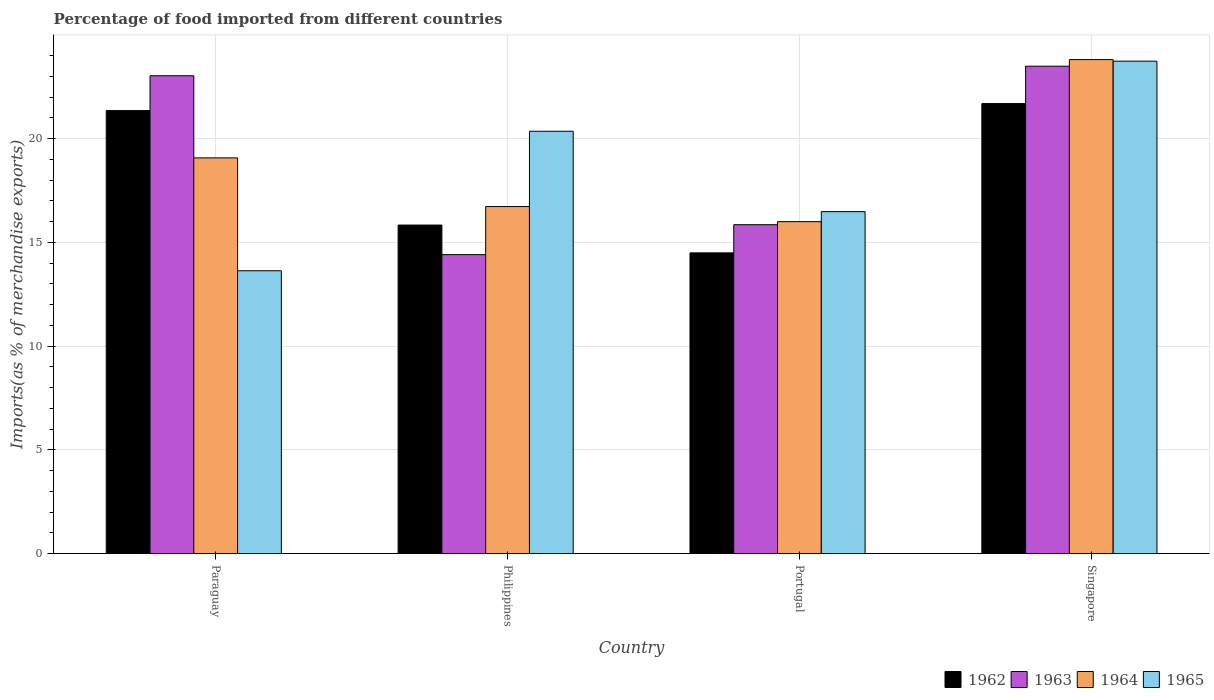How many different coloured bars are there?
Ensure brevity in your answer.  4. Are the number of bars on each tick of the X-axis equal?
Your answer should be very brief. Yes. How many bars are there on the 2nd tick from the left?
Keep it short and to the point. 4. How many bars are there on the 4th tick from the right?
Offer a very short reply. 4. What is the label of the 1st group of bars from the left?
Ensure brevity in your answer.  Paraguay. What is the percentage of imports to different countries in 1963 in Paraguay?
Your answer should be very brief. 23.03. Across all countries, what is the maximum percentage of imports to different countries in 1964?
Ensure brevity in your answer.  23.81. Across all countries, what is the minimum percentage of imports to different countries in 1963?
Keep it short and to the point. 14.41. In which country was the percentage of imports to different countries in 1965 maximum?
Provide a short and direct response. Singapore. What is the total percentage of imports to different countries in 1963 in the graph?
Ensure brevity in your answer.  76.78. What is the difference between the percentage of imports to different countries in 1962 in Portugal and that in Singapore?
Keep it short and to the point. -7.19. What is the difference between the percentage of imports to different countries in 1962 in Singapore and the percentage of imports to different countries in 1964 in Portugal?
Provide a short and direct response. 5.69. What is the average percentage of imports to different countries in 1964 per country?
Make the answer very short. 18.9. What is the difference between the percentage of imports to different countries of/in 1962 and percentage of imports to different countries of/in 1965 in Singapore?
Your answer should be compact. -2.04. In how many countries, is the percentage of imports to different countries in 1965 greater than 6 %?
Provide a succinct answer. 4. What is the ratio of the percentage of imports to different countries in 1963 in Paraguay to that in Philippines?
Your answer should be compact. 1.6. Is the percentage of imports to different countries in 1963 in Philippines less than that in Portugal?
Provide a succinct answer. Yes. Is the difference between the percentage of imports to different countries in 1962 in Paraguay and Singapore greater than the difference between the percentage of imports to different countries in 1965 in Paraguay and Singapore?
Ensure brevity in your answer.  Yes. What is the difference between the highest and the second highest percentage of imports to different countries in 1964?
Your answer should be compact. -2.35. What is the difference between the highest and the lowest percentage of imports to different countries in 1965?
Your answer should be compact. 10.1. Is the sum of the percentage of imports to different countries in 1964 in Paraguay and Portugal greater than the maximum percentage of imports to different countries in 1965 across all countries?
Your answer should be very brief. Yes. What does the 1st bar from the left in Paraguay represents?
Keep it short and to the point. 1962. How many bars are there?
Make the answer very short. 16. What is the difference between two consecutive major ticks on the Y-axis?
Offer a terse response. 5. Are the values on the major ticks of Y-axis written in scientific E-notation?
Provide a short and direct response. No. Where does the legend appear in the graph?
Offer a terse response. Bottom right. How many legend labels are there?
Offer a very short reply. 4. How are the legend labels stacked?
Your response must be concise. Horizontal. What is the title of the graph?
Offer a terse response. Percentage of food imported from different countries. Does "2010" appear as one of the legend labels in the graph?
Offer a terse response. No. What is the label or title of the Y-axis?
Provide a short and direct response. Imports(as % of merchandise exports). What is the Imports(as % of merchandise exports) of 1962 in Paraguay?
Ensure brevity in your answer.  21.35. What is the Imports(as % of merchandise exports) in 1963 in Paraguay?
Your answer should be compact. 23.03. What is the Imports(as % of merchandise exports) in 1964 in Paraguay?
Your answer should be compact. 19.07. What is the Imports(as % of merchandise exports) of 1965 in Paraguay?
Your answer should be very brief. 13.63. What is the Imports(as % of merchandise exports) in 1962 in Philippines?
Ensure brevity in your answer.  15.83. What is the Imports(as % of merchandise exports) of 1963 in Philippines?
Your response must be concise. 14.41. What is the Imports(as % of merchandise exports) in 1964 in Philippines?
Ensure brevity in your answer.  16.73. What is the Imports(as % of merchandise exports) of 1965 in Philippines?
Provide a short and direct response. 20.35. What is the Imports(as % of merchandise exports) in 1962 in Portugal?
Your response must be concise. 14.49. What is the Imports(as % of merchandise exports) in 1963 in Portugal?
Offer a terse response. 15.85. What is the Imports(as % of merchandise exports) of 1964 in Portugal?
Give a very brief answer. 16. What is the Imports(as % of merchandise exports) in 1965 in Portugal?
Offer a terse response. 16.48. What is the Imports(as % of merchandise exports) of 1962 in Singapore?
Provide a short and direct response. 21.69. What is the Imports(as % of merchandise exports) in 1963 in Singapore?
Provide a succinct answer. 23.49. What is the Imports(as % of merchandise exports) of 1964 in Singapore?
Make the answer very short. 23.81. What is the Imports(as % of merchandise exports) in 1965 in Singapore?
Give a very brief answer. 23.73. Across all countries, what is the maximum Imports(as % of merchandise exports) in 1962?
Give a very brief answer. 21.69. Across all countries, what is the maximum Imports(as % of merchandise exports) in 1963?
Your response must be concise. 23.49. Across all countries, what is the maximum Imports(as % of merchandise exports) of 1964?
Offer a very short reply. 23.81. Across all countries, what is the maximum Imports(as % of merchandise exports) in 1965?
Provide a short and direct response. 23.73. Across all countries, what is the minimum Imports(as % of merchandise exports) of 1962?
Offer a terse response. 14.49. Across all countries, what is the minimum Imports(as % of merchandise exports) in 1963?
Your answer should be compact. 14.41. Across all countries, what is the minimum Imports(as % of merchandise exports) in 1964?
Provide a short and direct response. 16. Across all countries, what is the minimum Imports(as % of merchandise exports) in 1965?
Make the answer very short. 13.63. What is the total Imports(as % of merchandise exports) in 1962 in the graph?
Offer a terse response. 73.37. What is the total Imports(as % of merchandise exports) of 1963 in the graph?
Ensure brevity in your answer.  76.78. What is the total Imports(as % of merchandise exports) in 1964 in the graph?
Ensure brevity in your answer.  75.61. What is the total Imports(as % of merchandise exports) in 1965 in the graph?
Provide a succinct answer. 74.2. What is the difference between the Imports(as % of merchandise exports) of 1962 in Paraguay and that in Philippines?
Provide a succinct answer. 5.52. What is the difference between the Imports(as % of merchandise exports) of 1963 in Paraguay and that in Philippines?
Your answer should be very brief. 8.62. What is the difference between the Imports(as % of merchandise exports) in 1964 in Paraguay and that in Philippines?
Your answer should be very brief. 2.35. What is the difference between the Imports(as % of merchandise exports) of 1965 in Paraguay and that in Philippines?
Provide a succinct answer. -6.72. What is the difference between the Imports(as % of merchandise exports) of 1962 in Paraguay and that in Portugal?
Make the answer very short. 6.86. What is the difference between the Imports(as % of merchandise exports) in 1963 in Paraguay and that in Portugal?
Your answer should be compact. 7.18. What is the difference between the Imports(as % of merchandise exports) in 1964 in Paraguay and that in Portugal?
Your answer should be very brief. 3.07. What is the difference between the Imports(as % of merchandise exports) in 1965 in Paraguay and that in Portugal?
Your answer should be compact. -2.85. What is the difference between the Imports(as % of merchandise exports) in 1962 in Paraguay and that in Singapore?
Provide a succinct answer. -0.34. What is the difference between the Imports(as % of merchandise exports) in 1963 in Paraguay and that in Singapore?
Your response must be concise. -0.46. What is the difference between the Imports(as % of merchandise exports) in 1964 in Paraguay and that in Singapore?
Keep it short and to the point. -4.74. What is the difference between the Imports(as % of merchandise exports) in 1965 in Paraguay and that in Singapore?
Offer a terse response. -10.1. What is the difference between the Imports(as % of merchandise exports) in 1962 in Philippines and that in Portugal?
Your response must be concise. 1.34. What is the difference between the Imports(as % of merchandise exports) of 1963 in Philippines and that in Portugal?
Offer a terse response. -1.44. What is the difference between the Imports(as % of merchandise exports) in 1964 in Philippines and that in Portugal?
Your answer should be compact. 0.73. What is the difference between the Imports(as % of merchandise exports) of 1965 in Philippines and that in Portugal?
Give a very brief answer. 3.87. What is the difference between the Imports(as % of merchandise exports) of 1962 in Philippines and that in Singapore?
Your answer should be compact. -5.85. What is the difference between the Imports(as % of merchandise exports) in 1963 in Philippines and that in Singapore?
Provide a short and direct response. -9.08. What is the difference between the Imports(as % of merchandise exports) of 1964 in Philippines and that in Singapore?
Make the answer very short. -7.08. What is the difference between the Imports(as % of merchandise exports) in 1965 in Philippines and that in Singapore?
Make the answer very short. -3.38. What is the difference between the Imports(as % of merchandise exports) of 1962 in Portugal and that in Singapore?
Make the answer very short. -7.19. What is the difference between the Imports(as % of merchandise exports) in 1963 in Portugal and that in Singapore?
Your response must be concise. -7.64. What is the difference between the Imports(as % of merchandise exports) of 1964 in Portugal and that in Singapore?
Your answer should be very brief. -7.81. What is the difference between the Imports(as % of merchandise exports) of 1965 in Portugal and that in Singapore?
Provide a succinct answer. -7.25. What is the difference between the Imports(as % of merchandise exports) in 1962 in Paraguay and the Imports(as % of merchandise exports) in 1963 in Philippines?
Your answer should be very brief. 6.94. What is the difference between the Imports(as % of merchandise exports) of 1962 in Paraguay and the Imports(as % of merchandise exports) of 1964 in Philippines?
Keep it short and to the point. 4.62. What is the difference between the Imports(as % of merchandise exports) in 1963 in Paraguay and the Imports(as % of merchandise exports) in 1964 in Philippines?
Provide a short and direct response. 6.3. What is the difference between the Imports(as % of merchandise exports) in 1963 in Paraguay and the Imports(as % of merchandise exports) in 1965 in Philippines?
Provide a succinct answer. 2.67. What is the difference between the Imports(as % of merchandise exports) of 1964 in Paraguay and the Imports(as % of merchandise exports) of 1965 in Philippines?
Offer a very short reply. -1.28. What is the difference between the Imports(as % of merchandise exports) of 1962 in Paraguay and the Imports(as % of merchandise exports) of 1963 in Portugal?
Give a very brief answer. 5.5. What is the difference between the Imports(as % of merchandise exports) of 1962 in Paraguay and the Imports(as % of merchandise exports) of 1964 in Portugal?
Keep it short and to the point. 5.35. What is the difference between the Imports(as % of merchandise exports) in 1962 in Paraguay and the Imports(as % of merchandise exports) in 1965 in Portugal?
Provide a succinct answer. 4.87. What is the difference between the Imports(as % of merchandise exports) in 1963 in Paraguay and the Imports(as % of merchandise exports) in 1964 in Portugal?
Your answer should be compact. 7.03. What is the difference between the Imports(as % of merchandise exports) in 1963 in Paraguay and the Imports(as % of merchandise exports) in 1965 in Portugal?
Offer a very short reply. 6.55. What is the difference between the Imports(as % of merchandise exports) of 1964 in Paraguay and the Imports(as % of merchandise exports) of 1965 in Portugal?
Your answer should be compact. 2.59. What is the difference between the Imports(as % of merchandise exports) of 1962 in Paraguay and the Imports(as % of merchandise exports) of 1963 in Singapore?
Offer a very short reply. -2.14. What is the difference between the Imports(as % of merchandise exports) in 1962 in Paraguay and the Imports(as % of merchandise exports) in 1964 in Singapore?
Give a very brief answer. -2.46. What is the difference between the Imports(as % of merchandise exports) in 1962 in Paraguay and the Imports(as % of merchandise exports) in 1965 in Singapore?
Your answer should be compact. -2.38. What is the difference between the Imports(as % of merchandise exports) in 1963 in Paraguay and the Imports(as % of merchandise exports) in 1964 in Singapore?
Offer a terse response. -0.78. What is the difference between the Imports(as % of merchandise exports) of 1963 in Paraguay and the Imports(as % of merchandise exports) of 1965 in Singapore?
Ensure brevity in your answer.  -0.7. What is the difference between the Imports(as % of merchandise exports) in 1964 in Paraguay and the Imports(as % of merchandise exports) in 1965 in Singapore?
Make the answer very short. -4.66. What is the difference between the Imports(as % of merchandise exports) of 1962 in Philippines and the Imports(as % of merchandise exports) of 1963 in Portugal?
Offer a very short reply. -0.02. What is the difference between the Imports(as % of merchandise exports) of 1962 in Philippines and the Imports(as % of merchandise exports) of 1964 in Portugal?
Your answer should be compact. -0.16. What is the difference between the Imports(as % of merchandise exports) of 1962 in Philippines and the Imports(as % of merchandise exports) of 1965 in Portugal?
Provide a succinct answer. -0.65. What is the difference between the Imports(as % of merchandise exports) of 1963 in Philippines and the Imports(as % of merchandise exports) of 1964 in Portugal?
Offer a terse response. -1.59. What is the difference between the Imports(as % of merchandise exports) of 1963 in Philippines and the Imports(as % of merchandise exports) of 1965 in Portugal?
Your response must be concise. -2.07. What is the difference between the Imports(as % of merchandise exports) in 1964 in Philippines and the Imports(as % of merchandise exports) in 1965 in Portugal?
Ensure brevity in your answer.  0.24. What is the difference between the Imports(as % of merchandise exports) of 1962 in Philippines and the Imports(as % of merchandise exports) of 1963 in Singapore?
Your answer should be compact. -7.65. What is the difference between the Imports(as % of merchandise exports) in 1962 in Philippines and the Imports(as % of merchandise exports) in 1964 in Singapore?
Make the answer very short. -7.97. What is the difference between the Imports(as % of merchandise exports) in 1962 in Philippines and the Imports(as % of merchandise exports) in 1965 in Singapore?
Ensure brevity in your answer.  -7.9. What is the difference between the Imports(as % of merchandise exports) in 1963 in Philippines and the Imports(as % of merchandise exports) in 1964 in Singapore?
Offer a very short reply. -9.4. What is the difference between the Imports(as % of merchandise exports) of 1963 in Philippines and the Imports(as % of merchandise exports) of 1965 in Singapore?
Your response must be concise. -9.32. What is the difference between the Imports(as % of merchandise exports) of 1964 in Philippines and the Imports(as % of merchandise exports) of 1965 in Singapore?
Ensure brevity in your answer.  -7.01. What is the difference between the Imports(as % of merchandise exports) in 1962 in Portugal and the Imports(as % of merchandise exports) in 1963 in Singapore?
Your answer should be compact. -8.99. What is the difference between the Imports(as % of merchandise exports) of 1962 in Portugal and the Imports(as % of merchandise exports) of 1964 in Singapore?
Offer a very short reply. -9.31. What is the difference between the Imports(as % of merchandise exports) of 1962 in Portugal and the Imports(as % of merchandise exports) of 1965 in Singapore?
Offer a terse response. -9.24. What is the difference between the Imports(as % of merchandise exports) in 1963 in Portugal and the Imports(as % of merchandise exports) in 1964 in Singapore?
Your response must be concise. -7.96. What is the difference between the Imports(as % of merchandise exports) in 1963 in Portugal and the Imports(as % of merchandise exports) in 1965 in Singapore?
Ensure brevity in your answer.  -7.88. What is the difference between the Imports(as % of merchandise exports) of 1964 in Portugal and the Imports(as % of merchandise exports) of 1965 in Singapore?
Keep it short and to the point. -7.73. What is the average Imports(as % of merchandise exports) in 1962 per country?
Provide a succinct answer. 18.34. What is the average Imports(as % of merchandise exports) of 1963 per country?
Provide a short and direct response. 19.2. What is the average Imports(as % of merchandise exports) in 1964 per country?
Your response must be concise. 18.9. What is the average Imports(as % of merchandise exports) in 1965 per country?
Provide a short and direct response. 18.55. What is the difference between the Imports(as % of merchandise exports) of 1962 and Imports(as % of merchandise exports) of 1963 in Paraguay?
Keep it short and to the point. -1.68. What is the difference between the Imports(as % of merchandise exports) in 1962 and Imports(as % of merchandise exports) in 1964 in Paraguay?
Provide a short and direct response. 2.28. What is the difference between the Imports(as % of merchandise exports) in 1962 and Imports(as % of merchandise exports) in 1965 in Paraguay?
Your response must be concise. 7.72. What is the difference between the Imports(as % of merchandise exports) in 1963 and Imports(as % of merchandise exports) in 1964 in Paraguay?
Make the answer very short. 3.96. What is the difference between the Imports(as % of merchandise exports) of 1963 and Imports(as % of merchandise exports) of 1965 in Paraguay?
Ensure brevity in your answer.  9.4. What is the difference between the Imports(as % of merchandise exports) of 1964 and Imports(as % of merchandise exports) of 1965 in Paraguay?
Your answer should be very brief. 5.44. What is the difference between the Imports(as % of merchandise exports) of 1962 and Imports(as % of merchandise exports) of 1963 in Philippines?
Your response must be concise. 1.43. What is the difference between the Imports(as % of merchandise exports) in 1962 and Imports(as % of merchandise exports) in 1964 in Philippines?
Give a very brief answer. -0.89. What is the difference between the Imports(as % of merchandise exports) of 1962 and Imports(as % of merchandise exports) of 1965 in Philippines?
Give a very brief answer. -4.52. What is the difference between the Imports(as % of merchandise exports) of 1963 and Imports(as % of merchandise exports) of 1964 in Philippines?
Your answer should be compact. -2.32. What is the difference between the Imports(as % of merchandise exports) in 1963 and Imports(as % of merchandise exports) in 1965 in Philippines?
Ensure brevity in your answer.  -5.94. What is the difference between the Imports(as % of merchandise exports) in 1964 and Imports(as % of merchandise exports) in 1965 in Philippines?
Make the answer very short. -3.63. What is the difference between the Imports(as % of merchandise exports) of 1962 and Imports(as % of merchandise exports) of 1963 in Portugal?
Provide a succinct answer. -1.36. What is the difference between the Imports(as % of merchandise exports) of 1962 and Imports(as % of merchandise exports) of 1964 in Portugal?
Your response must be concise. -1.5. What is the difference between the Imports(as % of merchandise exports) in 1962 and Imports(as % of merchandise exports) in 1965 in Portugal?
Your answer should be compact. -1.99. What is the difference between the Imports(as % of merchandise exports) of 1963 and Imports(as % of merchandise exports) of 1964 in Portugal?
Provide a short and direct response. -0.15. What is the difference between the Imports(as % of merchandise exports) in 1963 and Imports(as % of merchandise exports) in 1965 in Portugal?
Give a very brief answer. -0.63. What is the difference between the Imports(as % of merchandise exports) in 1964 and Imports(as % of merchandise exports) in 1965 in Portugal?
Offer a terse response. -0.48. What is the difference between the Imports(as % of merchandise exports) of 1962 and Imports(as % of merchandise exports) of 1963 in Singapore?
Your response must be concise. -1.8. What is the difference between the Imports(as % of merchandise exports) in 1962 and Imports(as % of merchandise exports) in 1964 in Singapore?
Make the answer very short. -2.12. What is the difference between the Imports(as % of merchandise exports) of 1962 and Imports(as % of merchandise exports) of 1965 in Singapore?
Keep it short and to the point. -2.04. What is the difference between the Imports(as % of merchandise exports) of 1963 and Imports(as % of merchandise exports) of 1964 in Singapore?
Keep it short and to the point. -0.32. What is the difference between the Imports(as % of merchandise exports) of 1963 and Imports(as % of merchandise exports) of 1965 in Singapore?
Keep it short and to the point. -0.24. What is the difference between the Imports(as % of merchandise exports) in 1964 and Imports(as % of merchandise exports) in 1965 in Singapore?
Your answer should be compact. 0.08. What is the ratio of the Imports(as % of merchandise exports) of 1962 in Paraguay to that in Philippines?
Offer a very short reply. 1.35. What is the ratio of the Imports(as % of merchandise exports) of 1963 in Paraguay to that in Philippines?
Make the answer very short. 1.6. What is the ratio of the Imports(as % of merchandise exports) of 1964 in Paraguay to that in Philippines?
Offer a very short reply. 1.14. What is the ratio of the Imports(as % of merchandise exports) in 1965 in Paraguay to that in Philippines?
Offer a terse response. 0.67. What is the ratio of the Imports(as % of merchandise exports) of 1962 in Paraguay to that in Portugal?
Offer a very short reply. 1.47. What is the ratio of the Imports(as % of merchandise exports) in 1963 in Paraguay to that in Portugal?
Provide a succinct answer. 1.45. What is the ratio of the Imports(as % of merchandise exports) of 1964 in Paraguay to that in Portugal?
Keep it short and to the point. 1.19. What is the ratio of the Imports(as % of merchandise exports) in 1965 in Paraguay to that in Portugal?
Your answer should be very brief. 0.83. What is the ratio of the Imports(as % of merchandise exports) of 1962 in Paraguay to that in Singapore?
Offer a very short reply. 0.98. What is the ratio of the Imports(as % of merchandise exports) in 1963 in Paraguay to that in Singapore?
Ensure brevity in your answer.  0.98. What is the ratio of the Imports(as % of merchandise exports) in 1964 in Paraguay to that in Singapore?
Your answer should be compact. 0.8. What is the ratio of the Imports(as % of merchandise exports) in 1965 in Paraguay to that in Singapore?
Give a very brief answer. 0.57. What is the ratio of the Imports(as % of merchandise exports) in 1962 in Philippines to that in Portugal?
Your answer should be compact. 1.09. What is the ratio of the Imports(as % of merchandise exports) of 1963 in Philippines to that in Portugal?
Give a very brief answer. 0.91. What is the ratio of the Imports(as % of merchandise exports) in 1964 in Philippines to that in Portugal?
Provide a succinct answer. 1.05. What is the ratio of the Imports(as % of merchandise exports) in 1965 in Philippines to that in Portugal?
Provide a short and direct response. 1.24. What is the ratio of the Imports(as % of merchandise exports) in 1962 in Philippines to that in Singapore?
Your answer should be compact. 0.73. What is the ratio of the Imports(as % of merchandise exports) in 1963 in Philippines to that in Singapore?
Offer a terse response. 0.61. What is the ratio of the Imports(as % of merchandise exports) of 1964 in Philippines to that in Singapore?
Provide a succinct answer. 0.7. What is the ratio of the Imports(as % of merchandise exports) of 1965 in Philippines to that in Singapore?
Give a very brief answer. 0.86. What is the ratio of the Imports(as % of merchandise exports) in 1962 in Portugal to that in Singapore?
Provide a short and direct response. 0.67. What is the ratio of the Imports(as % of merchandise exports) of 1963 in Portugal to that in Singapore?
Your answer should be compact. 0.67. What is the ratio of the Imports(as % of merchandise exports) of 1964 in Portugal to that in Singapore?
Offer a very short reply. 0.67. What is the ratio of the Imports(as % of merchandise exports) in 1965 in Portugal to that in Singapore?
Your answer should be very brief. 0.69. What is the difference between the highest and the second highest Imports(as % of merchandise exports) of 1962?
Provide a succinct answer. 0.34. What is the difference between the highest and the second highest Imports(as % of merchandise exports) in 1963?
Your answer should be compact. 0.46. What is the difference between the highest and the second highest Imports(as % of merchandise exports) of 1964?
Offer a terse response. 4.74. What is the difference between the highest and the second highest Imports(as % of merchandise exports) in 1965?
Give a very brief answer. 3.38. What is the difference between the highest and the lowest Imports(as % of merchandise exports) of 1962?
Provide a succinct answer. 7.19. What is the difference between the highest and the lowest Imports(as % of merchandise exports) of 1963?
Offer a terse response. 9.08. What is the difference between the highest and the lowest Imports(as % of merchandise exports) in 1964?
Make the answer very short. 7.81. What is the difference between the highest and the lowest Imports(as % of merchandise exports) in 1965?
Make the answer very short. 10.1. 